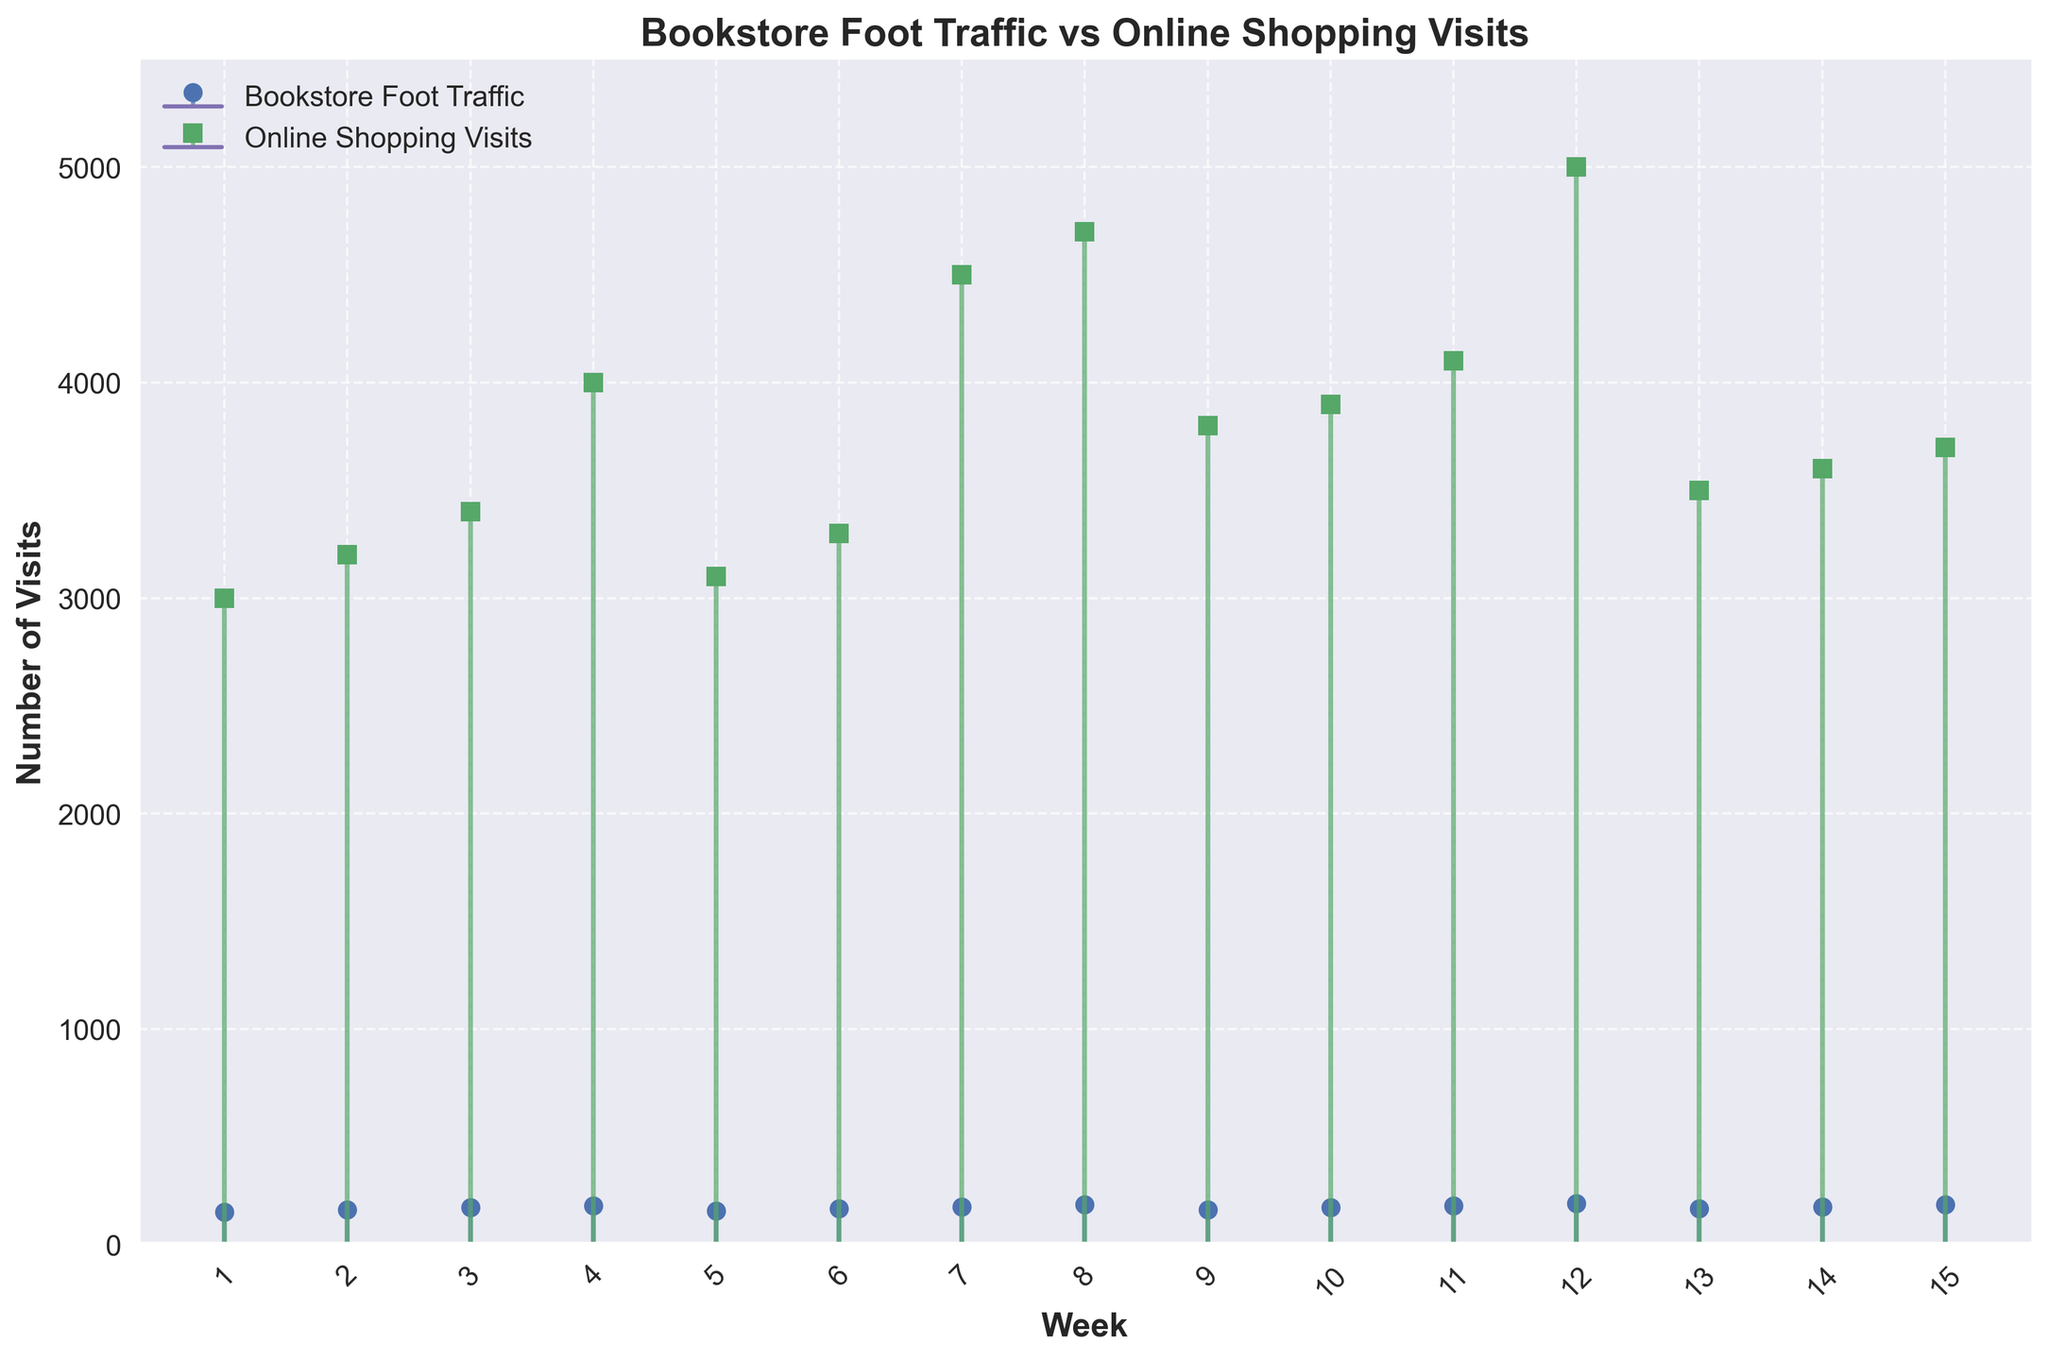How many weeks of data are represented in the figure? Count the number of data points along the x-axis. Each point represents a week.
Answer: 15 What is the title of the figure? Look at the top-center of the figure where the title is displayed.
Answer: Bookstore Foot Traffic vs Online Shopping Visits Which week had the highest number of online shopping visits? Look for the week where the stem line for Online Shopping Visits is the tallest. It's Week 12.
Answer: Week 12 What was the foot traffic in the independent bookstore during Week 4? Find Week 4 on the x-axis and look for the value associated with the "Bookstore Foot Traffic" stem.
Answer: 180 During which week did the independent bookstore have its lowest foot traffic? Look for the week where the stem line for “Bookstore Foot Traffic” is the shortest. It’s Week 1.
Answer: Week 1 What is the difference in online shopping visits between weeks 7 and 8? Subtract the number of online shopping visits in Week 7 from the number in Week 8. 4700 - 4500 = 200
Answer: 200 What is the average foot traffic at the independent bookstore over the 15 weeks? Sum the foot traffic values and divide by the number of weeks (15). (150 + 160 + 170 + 180 + 155 + 165 + 175 + 185 + 160 + 170 + 180 + 190 + 165 + 175 + 185) / 15 = 171
Answer: 171 Compare the foot traffic in the independent bookstore and online shopping visits during Week 10. Which is higher and by how much? Find the values for Week 10 for both foot traffic and online visits, then calculate the difference. Bookstore: 170, Online: 3900, Difference: 3900 - 170 = 3730
Answer: Online, 3730 더 많은 Is there any week where bookstore foot traffic equals online shopping visits? Check each week to see if the stem lines for the two categories are of equal length. There is no such week.
Answer: No How much did the foot traffic change between the first and last week? Subtract the first week's foot traffic from the last week's foot traffic. 185 - 150 = 35
Answer: 35 